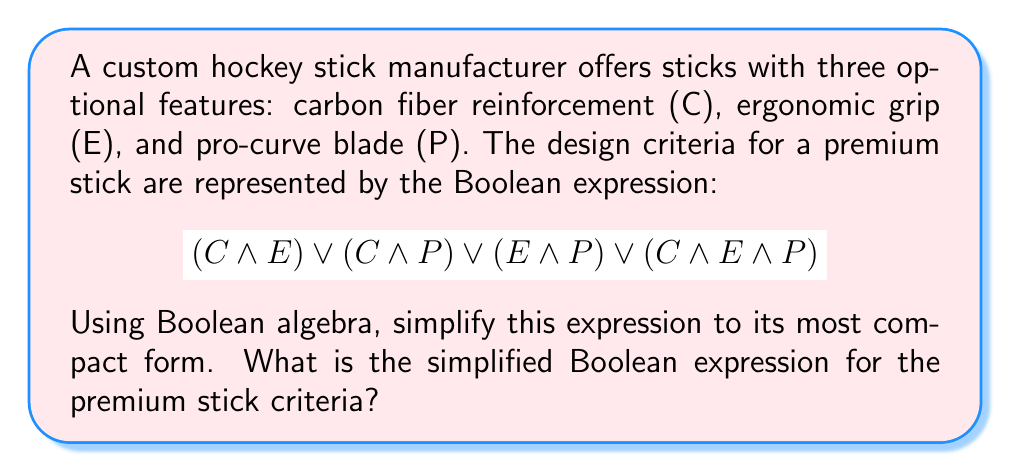Can you solve this math problem? Let's simplify the Boolean expression step by step using Boolean algebra laws:

1) First, we can use the associative and commutative properties to reorder the terms:
   $$(C \land E) \lor (C \land P) \lor (E \land P) \lor (C \land E \land P)$$

2) We can use the absorption law, which states that $A \lor (A \land B) = A$. Apply this to the first and last terms:
   $$(C \land E) \lor (C \land P) \lor (E \land P)$$
   The $(C \land E \land P)$ term is absorbed by $(C \land E)$.

3) Now, we can use the distributive law to factor out common terms:
   $$(C \land (E \lor P)) \lor (E \land P)$$

4) Using the distributive law again, we can expand this:
   $$(C \land E) \lor (C \land P) \lor (E \land P)$$

5) This is the same as our result from step 2, which means we've reached the simplest form using standard Boolean algebra laws.

6) However, we can use a less common but valid simplification. This expression represents all cases where at least two of the three variables are true. In Boolean algebra, this is equivalent to the majority function, which can be expressed as:
   $$(C \land E) \lor (E \land P) \lor (P \land C)$$

This final form is the most compact representation of the original expression.
Answer: $(C \land E) \lor (E \land P) \lor (P \land C)$ 